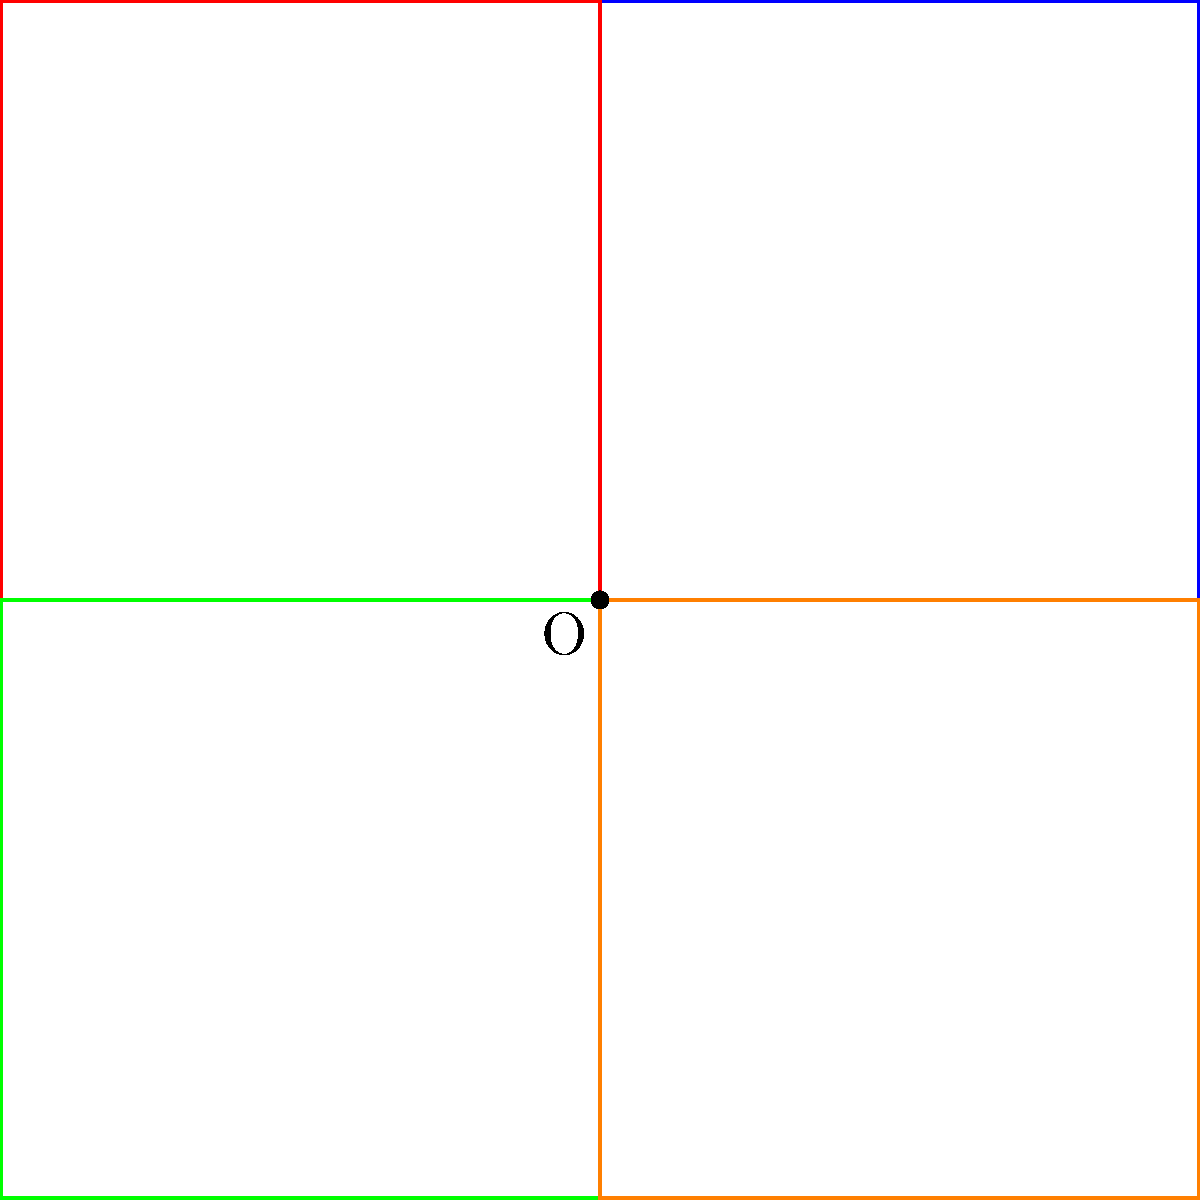Inspired by Theodore's interest in symmetry and patterns, we've created a figure by rotating a square around the origin. The original square has vertices at (0,0), (2,0), (2,2), and (0,2). What is the area of the resulting star-shaped figure formed by the overlapping squares? Let's approach this step-by-step:

1) First, we need to understand what the figure looks like. It's composed of four squares, each rotated 90° from the previous one around the origin.

2) The area of the star-shaped figure will be the sum of the areas of all four squares, minus the areas where they overlap.

3) Each square has a side length of 2 units, so its area is $2^2 = 4$ square units.

4) The total area of all four squares is $4 * 4 = 16$ square units.

5) Now, we need to subtract the overlapping areas. The squares overlap in the center, forming a smaller square.

6) This central square has vertices at (1,1), (-1,1), (-1,-1), and (1,-1). Its side length is 2 units, so its area is also 4 square units.

7) This central square is counted 4 times in our initial calculation, but it should only be counted once.

8) So we need to subtract 3 times the area of the central square: $3 * 4 = 12$ square units.

9) Therefore, the area of the star-shaped figure is:
   $16 - 12 = 4$ square units
Answer: 4 square units 